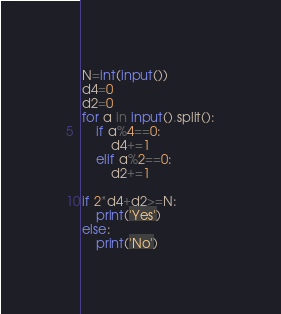Convert code to text. <code><loc_0><loc_0><loc_500><loc_500><_Python_>N=int(input())
d4=0
d2=0
for a in input().split():
    if a%4==0:
        d4+=1
    elif a%2==0:
        d2+=1

if 2*d4+d2>=N:
    print('Yes')
else:
    print('No')</code> 